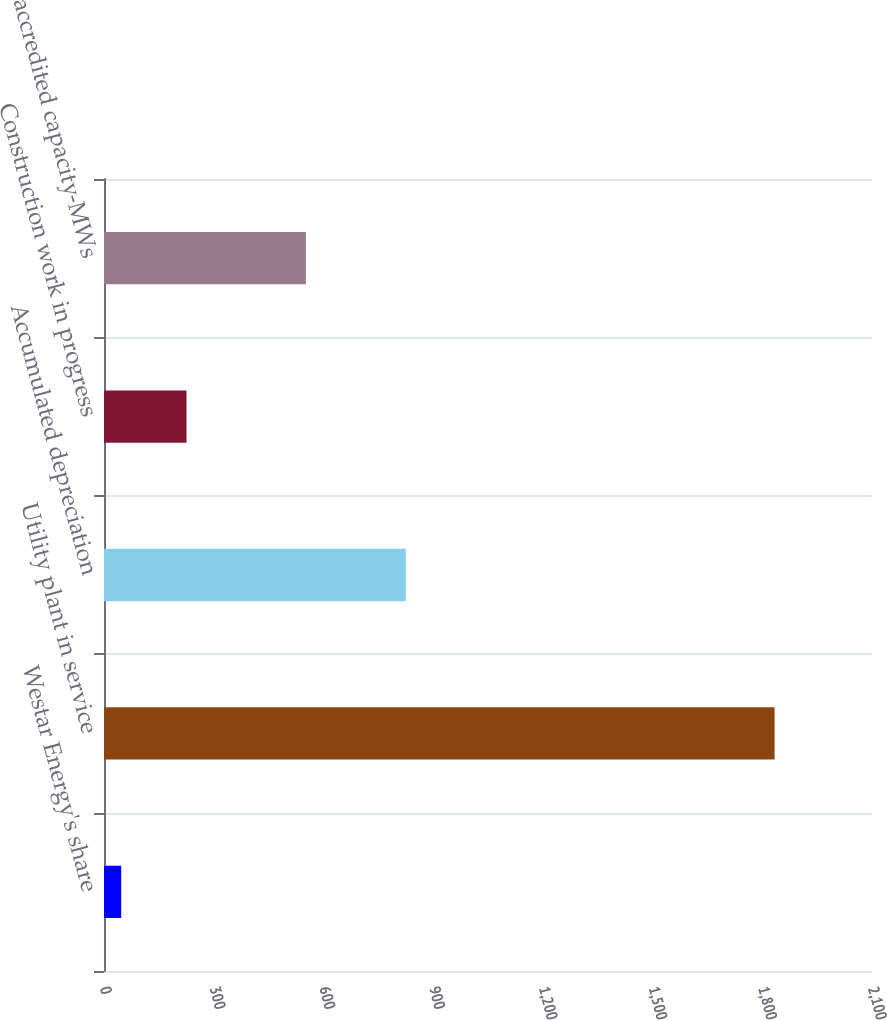<chart> <loc_0><loc_0><loc_500><loc_500><bar_chart><fcel>Westar Energy's share<fcel>Utility plant in service<fcel>Accumulated depreciation<fcel>Construction work in progress<fcel>2019 accredited capacity-MWs<nl><fcel>47<fcel>1833.7<fcel>825.3<fcel>225.67<fcel>552<nl></chart> 